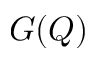Convert formula to latex. <formula><loc_0><loc_0><loc_500><loc_500>G ( Q )</formula> 